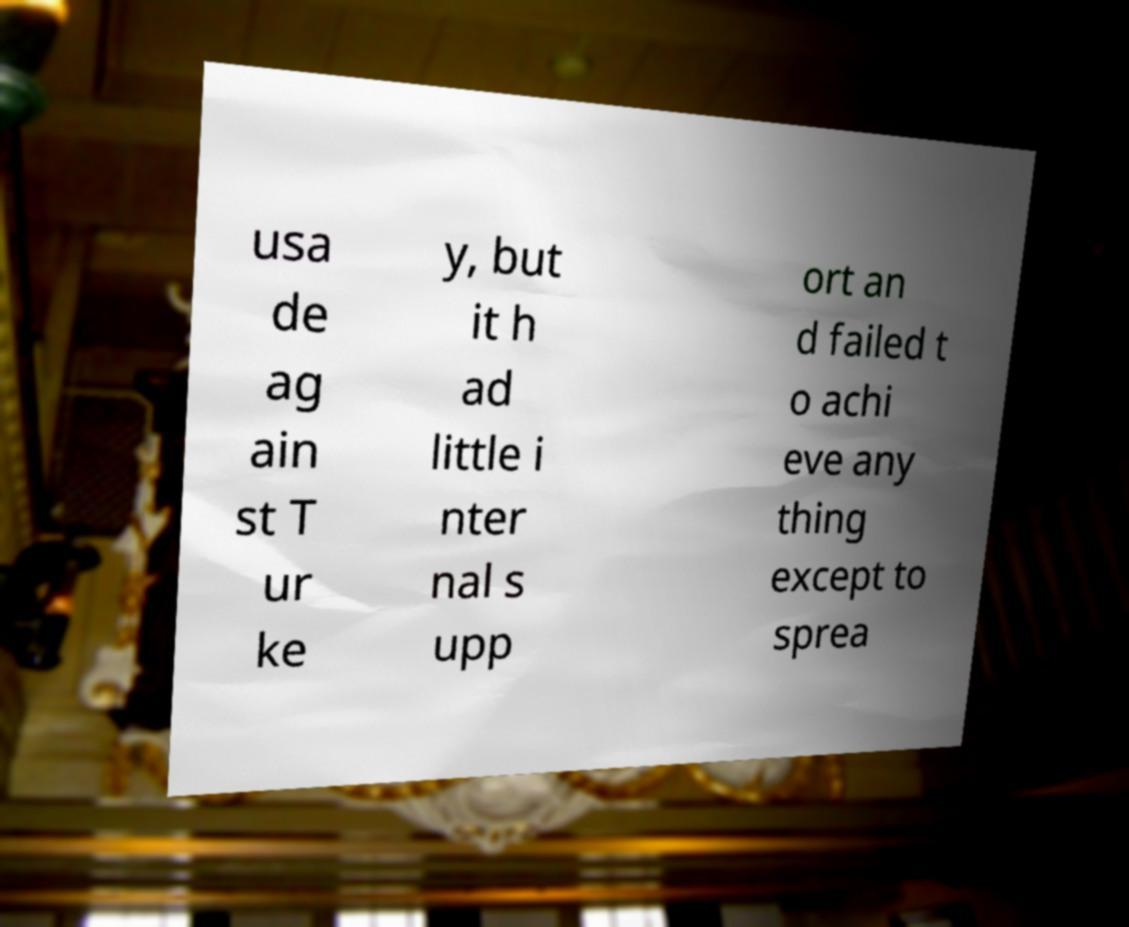I need the written content from this picture converted into text. Can you do that? usa de ag ain st T ur ke y, but it h ad little i nter nal s upp ort an d failed t o achi eve any thing except to sprea 